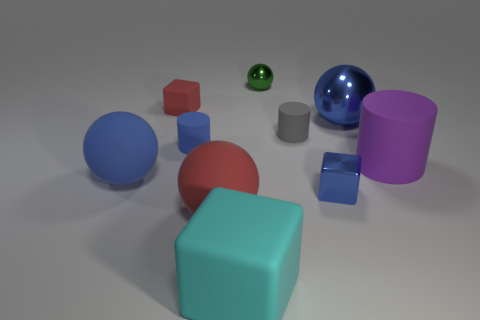There is a sphere that is in front of the small red block and behind the purple rubber cylinder; what material is it?
Give a very brief answer. Metal. Does the big shiny object have the same color as the metal block?
Ensure brevity in your answer.  Yes. Is there a red cylinder of the same size as the red matte cube?
Your answer should be compact. No. What number of objects are both in front of the big blue shiny thing and behind the blue block?
Make the answer very short. 4. What number of blocks are in front of the big blue rubber ball?
Make the answer very short. 2. Is there another big rubber thing that has the same shape as the large blue matte object?
Your answer should be compact. Yes. Do the big cyan object and the small blue object on the right side of the tiny green thing have the same shape?
Keep it short and to the point. Yes. What number of cubes are either small yellow metal objects or purple things?
Provide a short and direct response. 0. There is a small metallic thing that is in front of the tiny gray matte thing; what is its shape?
Your answer should be compact. Cube. How many other small gray objects are made of the same material as the gray thing?
Give a very brief answer. 0. 